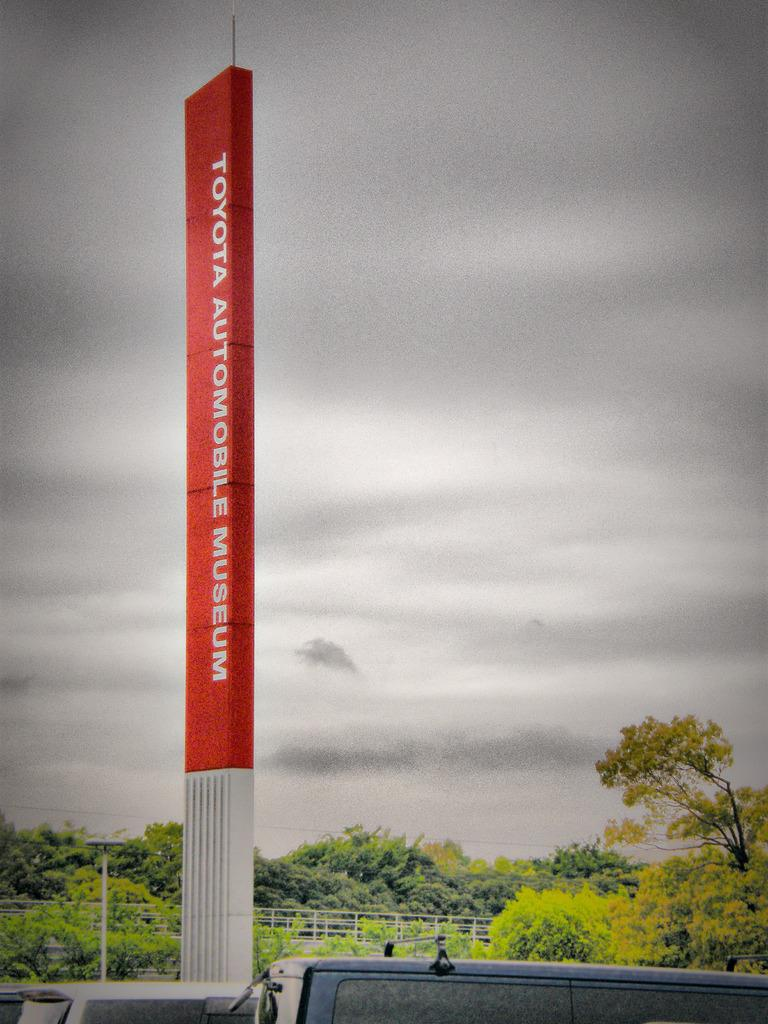<image>
Write a terse but informative summary of the picture. A large vertical sign in red reads "Toyota Automotive Museum." 